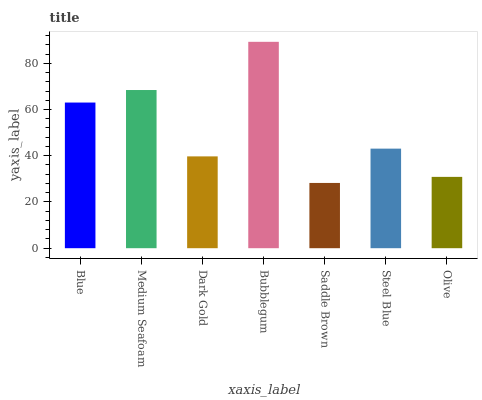Is Saddle Brown the minimum?
Answer yes or no. Yes. Is Bubblegum the maximum?
Answer yes or no. Yes. Is Medium Seafoam the minimum?
Answer yes or no. No. Is Medium Seafoam the maximum?
Answer yes or no. No. Is Medium Seafoam greater than Blue?
Answer yes or no. Yes. Is Blue less than Medium Seafoam?
Answer yes or no. Yes. Is Blue greater than Medium Seafoam?
Answer yes or no. No. Is Medium Seafoam less than Blue?
Answer yes or no. No. Is Steel Blue the high median?
Answer yes or no. Yes. Is Steel Blue the low median?
Answer yes or no. Yes. Is Medium Seafoam the high median?
Answer yes or no. No. Is Blue the low median?
Answer yes or no. No. 